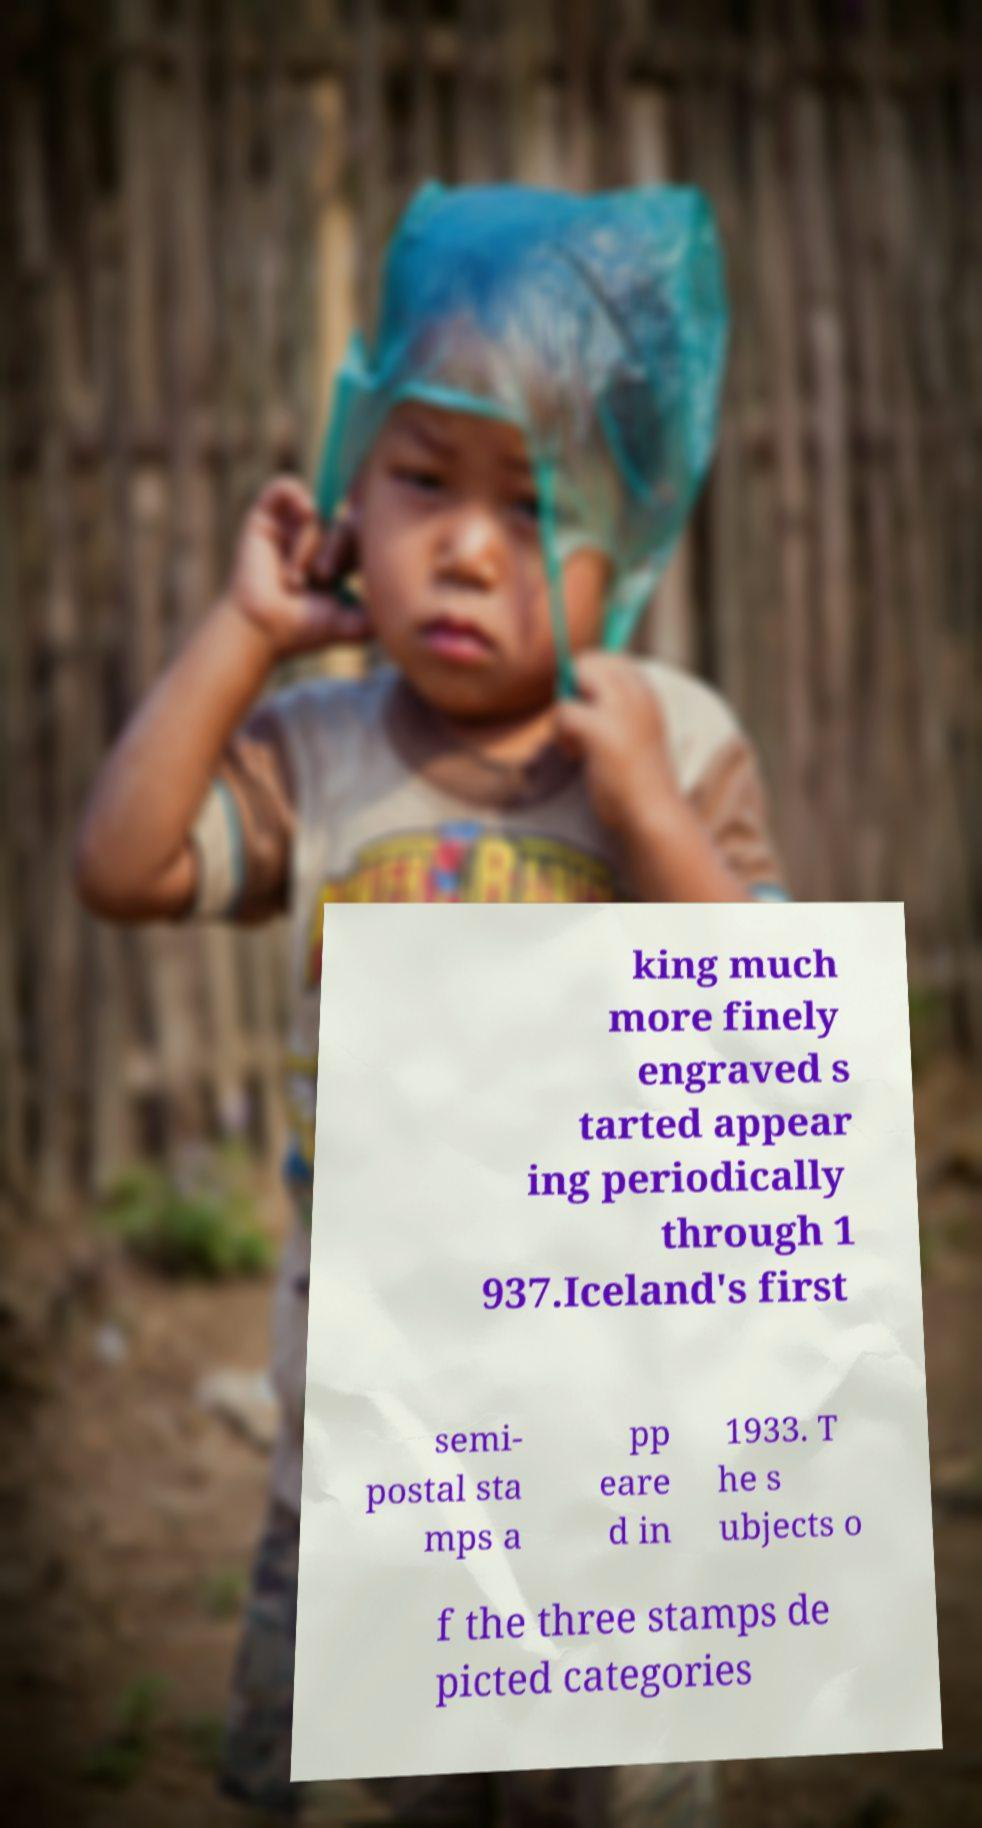I need the written content from this picture converted into text. Can you do that? king much more finely engraved s tarted appear ing periodically through 1 937.Iceland's first semi- postal sta mps a pp eare d in 1933. T he s ubjects o f the three stamps de picted categories 